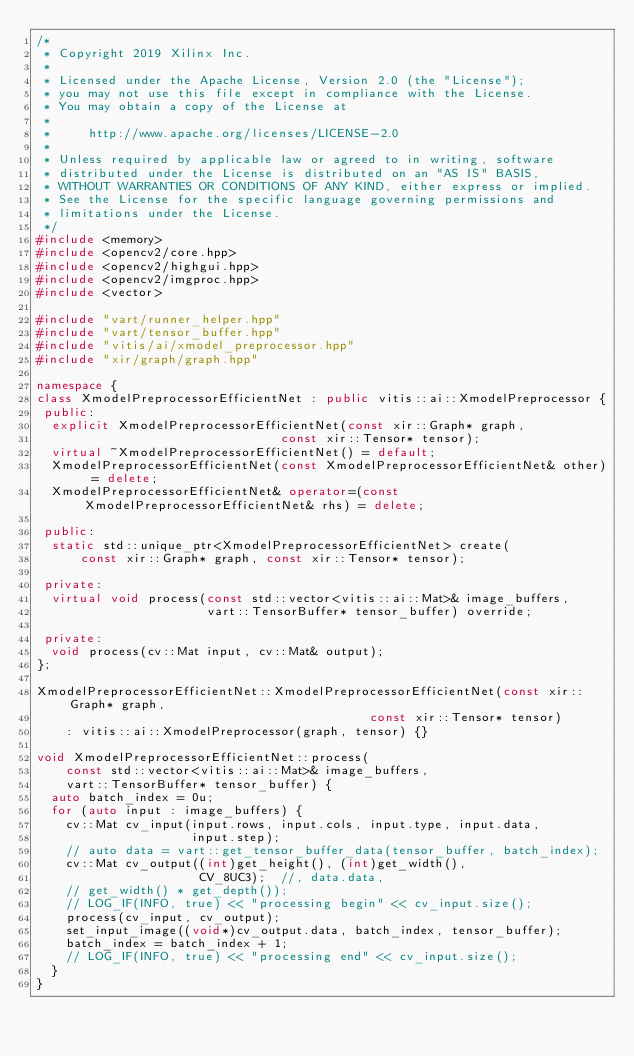Convert code to text. <code><loc_0><loc_0><loc_500><loc_500><_C++_>/*
 * Copyright 2019 Xilinx Inc.
 *
 * Licensed under the Apache License, Version 2.0 (the "License");
 * you may not use this file except in compliance with the License.
 * You may obtain a copy of the License at
 *
 *     http://www.apache.org/licenses/LICENSE-2.0
 *
 * Unless required by applicable law or agreed to in writing, software
 * distributed under the License is distributed on an "AS IS" BASIS,
 * WITHOUT WARRANTIES OR CONDITIONS OF ANY KIND, either express or implied.
 * See the License for the specific language governing permissions and
 * limitations under the License.
 */
#include <memory>
#include <opencv2/core.hpp>
#include <opencv2/highgui.hpp>
#include <opencv2/imgproc.hpp>
#include <vector>

#include "vart/runner_helper.hpp"
#include "vart/tensor_buffer.hpp"
#include "vitis/ai/xmodel_preprocessor.hpp"
#include "xir/graph/graph.hpp"

namespace {
class XmodelPreprocessorEfficientNet : public vitis::ai::XmodelPreprocessor {
 public:
  explicit XmodelPreprocessorEfficientNet(const xir::Graph* graph,
                                 const xir::Tensor* tensor);
  virtual ~XmodelPreprocessorEfficientNet() = default;
  XmodelPreprocessorEfficientNet(const XmodelPreprocessorEfficientNet& other) = delete;
  XmodelPreprocessorEfficientNet& operator=(const XmodelPreprocessorEfficientNet& rhs) = delete;

 public:
  static std::unique_ptr<XmodelPreprocessorEfficientNet> create(
      const xir::Graph* graph, const xir::Tensor* tensor);

 private:
  virtual void process(const std::vector<vitis::ai::Mat>& image_buffers,
                       vart::TensorBuffer* tensor_buffer) override;

 private:
  void process(cv::Mat input, cv::Mat& output);
};

XmodelPreprocessorEfficientNet::XmodelPreprocessorEfficientNet(const xir::Graph* graph,
                                             const xir::Tensor* tensor)
    : vitis::ai::XmodelPreprocessor(graph, tensor) {}

void XmodelPreprocessorEfficientNet::process(
    const std::vector<vitis::ai::Mat>& image_buffers,
    vart::TensorBuffer* tensor_buffer) {
  auto batch_index = 0u;
  for (auto input : image_buffers) {
    cv::Mat cv_input(input.rows, input.cols, input.type, input.data,
                     input.step);
    // auto data = vart::get_tensor_buffer_data(tensor_buffer, batch_index);
    cv::Mat cv_output((int)get_height(), (int)get_width(),
                      CV_8UC3);  //, data.data,
    // get_width() * get_depth());
    // LOG_IF(INFO, true) << "processing begin" << cv_input.size();
    process(cv_input, cv_output);
    set_input_image((void*)cv_output.data, batch_index, tensor_buffer);
    batch_index = batch_index + 1;
    // LOG_IF(INFO, true) << "processing end" << cv_input.size();
  }
}
</code> 